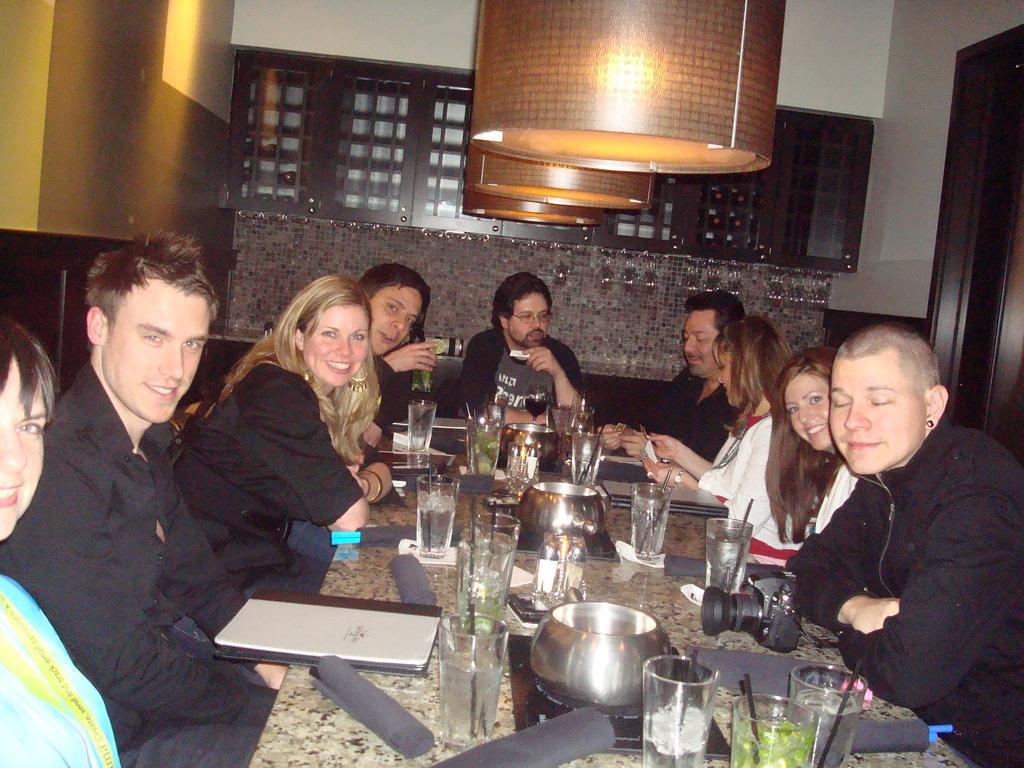Could you give a brief overview of what you see in this image? Group of people sitting. We can see glasses,bowls and things on the table. On the background we can see wall. On the top we can see lights. 